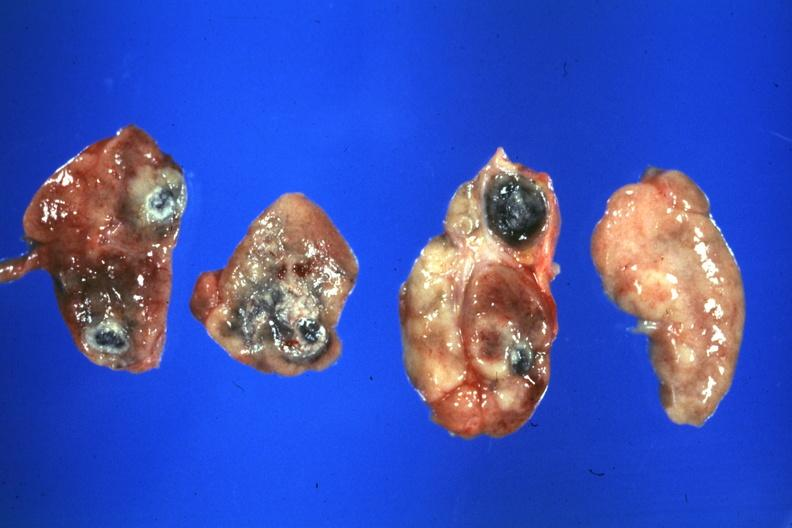s chronic myelogenous leukemia in blast crisis present?
Answer the question using a single word or phrase. No 